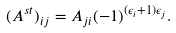<formula> <loc_0><loc_0><loc_500><loc_500>( A ^ { s t } ) _ { i j } = A _ { j i } ( - 1 ) ^ { ( \epsilon _ { i } + 1 ) \epsilon _ { j } } .</formula> 